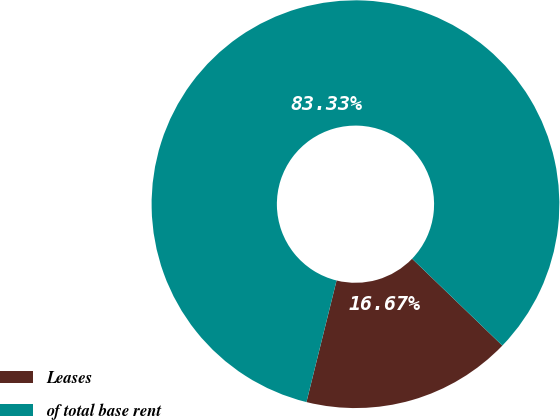Convert chart. <chart><loc_0><loc_0><loc_500><loc_500><pie_chart><fcel>Leases<fcel>of total base rent<nl><fcel>16.67%<fcel>83.33%<nl></chart> 